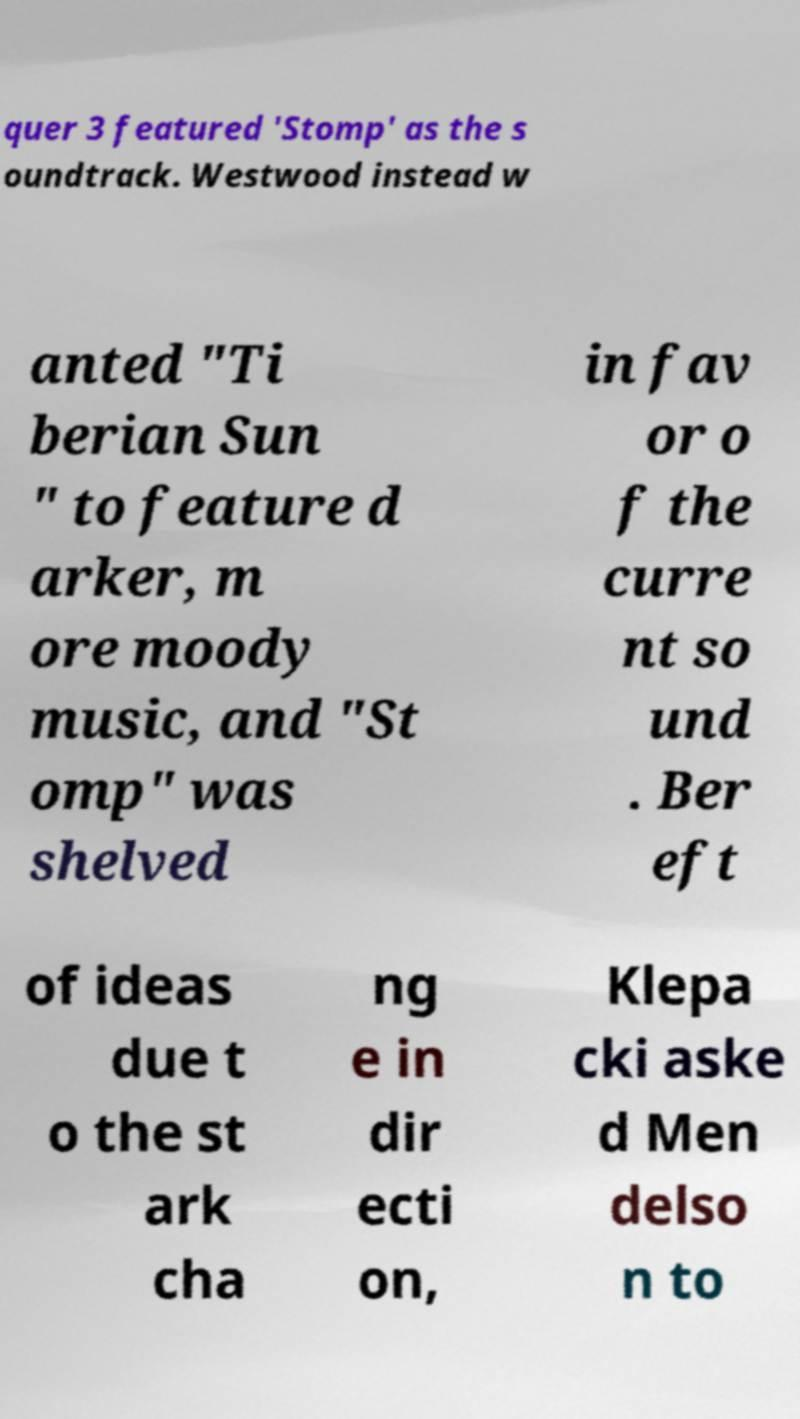There's text embedded in this image that I need extracted. Can you transcribe it verbatim? quer 3 featured 'Stomp' as the s oundtrack. Westwood instead w anted "Ti berian Sun " to feature d arker, m ore moody music, and "St omp" was shelved in fav or o f the curre nt so und . Ber eft of ideas due t o the st ark cha ng e in dir ecti on, Klepa cki aske d Men delso n to 